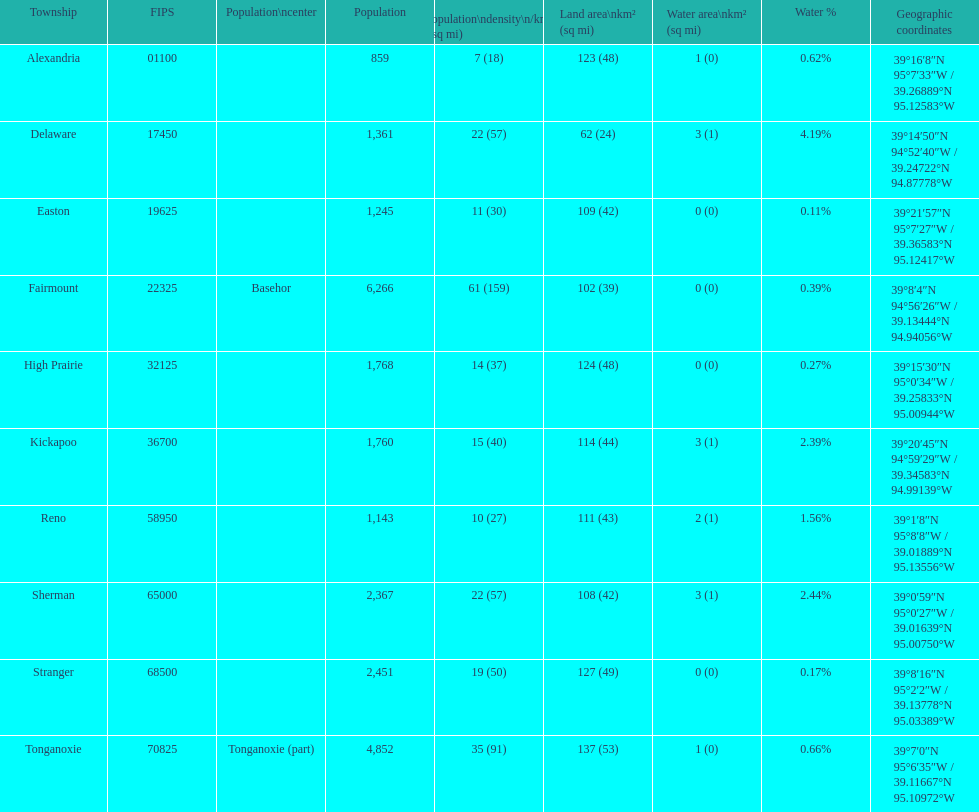What is the number of townships with a population larger than 2,000? 4. 